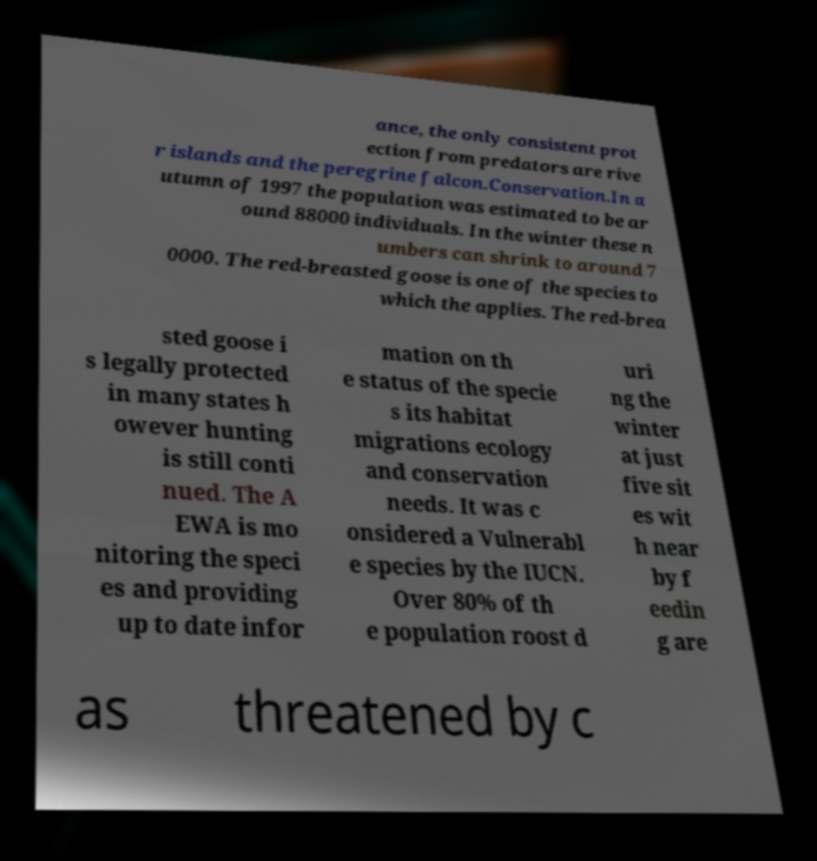I need the written content from this picture converted into text. Can you do that? ance, the only consistent prot ection from predators are rive r islands and the peregrine falcon.Conservation.In a utumn of 1997 the population was estimated to be ar ound 88000 individuals. In the winter these n umbers can shrink to around 7 0000. The red-breasted goose is one of the species to which the applies. The red-brea sted goose i s legally protected in many states h owever hunting is still conti nued. The A EWA is mo nitoring the speci es and providing up to date infor mation on th e status of the specie s its habitat migrations ecology and conservation needs. It was c onsidered a Vulnerabl e species by the IUCN. Over 80% of th e population roost d uri ng the winter at just five sit es wit h near by f eedin g are as threatened by c 